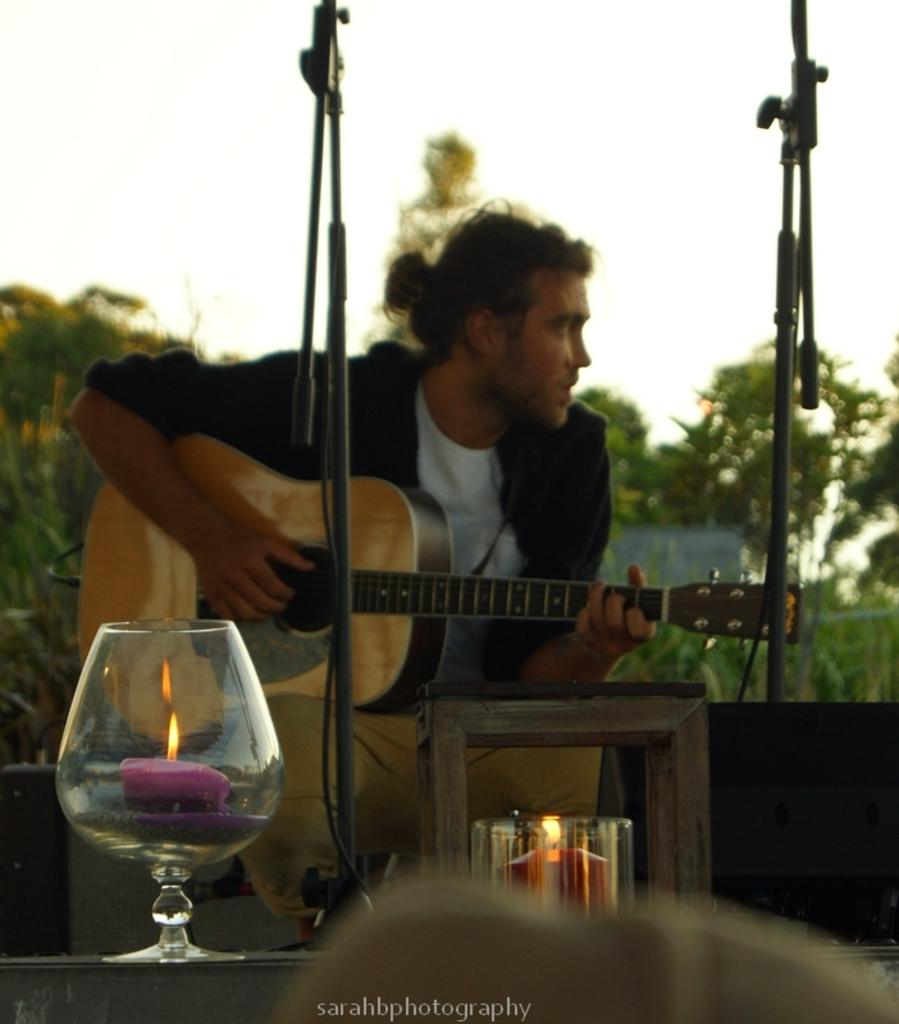Who is in the image? There is a person in the image. What is the person holding? The person is holding a guitar. What is on the table in front of the person? There is a glass on a table in front of the person. What is inside the glass? There is a candle inside the glass. What type of substance is the person using to play the guitar in the image? The person is not using any substance to play the guitar in the image; they are simply holding it. 